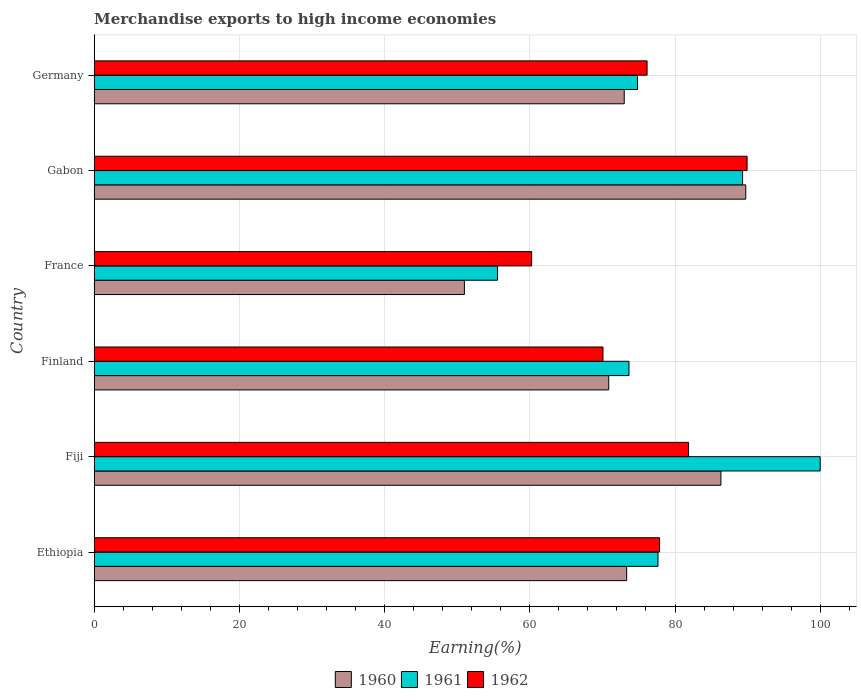How many groups of bars are there?
Offer a terse response. 6. Are the number of bars on each tick of the Y-axis equal?
Ensure brevity in your answer.  Yes. What is the label of the 5th group of bars from the top?
Ensure brevity in your answer.  Fiji. In how many cases, is the number of bars for a given country not equal to the number of legend labels?
Provide a succinct answer. 0. What is the percentage of amount earned from merchandise exports in 1960 in Ethiopia?
Make the answer very short. 73.34. Across all countries, what is the maximum percentage of amount earned from merchandise exports in 1962?
Provide a short and direct response. 89.93. Across all countries, what is the minimum percentage of amount earned from merchandise exports in 1960?
Your response must be concise. 50.99. In which country was the percentage of amount earned from merchandise exports in 1960 maximum?
Make the answer very short. Gabon. What is the total percentage of amount earned from merchandise exports in 1960 in the graph?
Keep it short and to the point. 444.29. What is the difference between the percentage of amount earned from merchandise exports in 1961 in France and that in Germany?
Make the answer very short. -19.28. What is the difference between the percentage of amount earned from merchandise exports in 1962 in Germany and the percentage of amount earned from merchandise exports in 1961 in Fiji?
Give a very brief answer. -23.85. What is the average percentage of amount earned from merchandise exports in 1962 per country?
Keep it short and to the point. 76.03. What is the difference between the percentage of amount earned from merchandise exports in 1962 and percentage of amount earned from merchandise exports in 1960 in France?
Your response must be concise. 9.26. In how many countries, is the percentage of amount earned from merchandise exports in 1961 greater than 88 %?
Offer a terse response. 2. What is the ratio of the percentage of amount earned from merchandise exports in 1962 in Ethiopia to that in Fiji?
Provide a short and direct response. 0.95. What is the difference between the highest and the second highest percentage of amount earned from merchandise exports in 1961?
Provide a succinct answer. 10.69. What is the difference between the highest and the lowest percentage of amount earned from merchandise exports in 1960?
Keep it short and to the point. 38.76. Is the sum of the percentage of amount earned from merchandise exports in 1961 in Fiji and Gabon greater than the maximum percentage of amount earned from merchandise exports in 1962 across all countries?
Ensure brevity in your answer.  Yes. Is it the case that in every country, the sum of the percentage of amount earned from merchandise exports in 1960 and percentage of amount earned from merchandise exports in 1961 is greater than the percentage of amount earned from merchandise exports in 1962?
Provide a short and direct response. Yes. How many countries are there in the graph?
Your response must be concise. 6. Are the values on the major ticks of X-axis written in scientific E-notation?
Give a very brief answer. No. Does the graph contain any zero values?
Your response must be concise. No. Does the graph contain grids?
Provide a succinct answer. Yes. What is the title of the graph?
Your answer should be very brief. Merchandise exports to high income economies. Does "1999" appear as one of the legend labels in the graph?
Offer a terse response. No. What is the label or title of the X-axis?
Your answer should be very brief. Earning(%). What is the label or title of the Y-axis?
Provide a succinct answer. Country. What is the Earning(%) in 1960 in Ethiopia?
Offer a very short reply. 73.34. What is the Earning(%) of 1961 in Ethiopia?
Your answer should be very brief. 77.66. What is the Earning(%) in 1962 in Ethiopia?
Your answer should be compact. 77.88. What is the Earning(%) of 1960 in Fiji?
Ensure brevity in your answer.  86.33. What is the Earning(%) in 1962 in Fiji?
Make the answer very short. 81.86. What is the Earning(%) of 1960 in Finland?
Make the answer very short. 70.87. What is the Earning(%) of 1961 in Finland?
Provide a succinct answer. 73.67. What is the Earning(%) of 1962 in Finland?
Your response must be concise. 70.08. What is the Earning(%) of 1960 in France?
Offer a terse response. 50.99. What is the Earning(%) of 1961 in France?
Keep it short and to the point. 55.56. What is the Earning(%) in 1962 in France?
Give a very brief answer. 60.25. What is the Earning(%) in 1960 in Gabon?
Keep it short and to the point. 89.75. What is the Earning(%) in 1961 in Gabon?
Provide a succinct answer. 89.31. What is the Earning(%) in 1962 in Gabon?
Make the answer very short. 89.93. What is the Earning(%) in 1960 in Germany?
Ensure brevity in your answer.  73.01. What is the Earning(%) of 1961 in Germany?
Offer a terse response. 74.84. What is the Earning(%) of 1962 in Germany?
Your answer should be compact. 76.15. Across all countries, what is the maximum Earning(%) in 1960?
Your response must be concise. 89.75. Across all countries, what is the maximum Earning(%) in 1961?
Offer a very short reply. 100. Across all countries, what is the maximum Earning(%) of 1962?
Ensure brevity in your answer.  89.93. Across all countries, what is the minimum Earning(%) of 1960?
Provide a short and direct response. 50.99. Across all countries, what is the minimum Earning(%) of 1961?
Offer a very short reply. 55.56. Across all countries, what is the minimum Earning(%) in 1962?
Ensure brevity in your answer.  60.25. What is the total Earning(%) in 1960 in the graph?
Ensure brevity in your answer.  444.29. What is the total Earning(%) in 1961 in the graph?
Ensure brevity in your answer.  471.03. What is the total Earning(%) of 1962 in the graph?
Your answer should be compact. 456.16. What is the difference between the Earning(%) of 1960 in Ethiopia and that in Fiji?
Your response must be concise. -12.99. What is the difference between the Earning(%) in 1961 in Ethiopia and that in Fiji?
Keep it short and to the point. -22.34. What is the difference between the Earning(%) in 1962 in Ethiopia and that in Fiji?
Your answer should be very brief. -3.99. What is the difference between the Earning(%) of 1960 in Ethiopia and that in Finland?
Your response must be concise. 2.47. What is the difference between the Earning(%) of 1961 in Ethiopia and that in Finland?
Keep it short and to the point. 3.99. What is the difference between the Earning(%) of 1962 in Ethiopia and that in Finland?
Offer a terse response. 7.8. What is the difference between the Earning(%) of 1960 in Ethiopia and that in France?
Your answer should be compact. 22.35. What is the difference between the Earning(%) of 1961 in Ethiopia and that in France?
Your response must be concise. 22.1. What is the difference between the Earning(%) in 1962 in Ethiopia and that in France?
Offer a terse response. 17.62. What is the difference between the Earning(%) of 1960 in Ethiopia and that in Gabon?
Provide a short and direct response. -16.41. What is the difference between the Earning(%) of 1961 in Ethiopia and that in Gabon?
Offer a very short reply. -11.65. What is the difference between the Earning(%) of 1962 in Ethiopia and that in Gabon?
Your answer should be compact. -12.06. What is the difference between the Earning(%) in 1960 in Ethiopia and that in Germany?
Keep it short and to the point. 0.33. What is the difference between the Earning(%) in 1961 in Ethiopia and that in Germany?
Keep it short and to the point. 2.82. What is the difference between the Earning(%) in 1962 in Ethiopia and that in Germany?
Offer a terse response. 1.72. What is the difference between the Earning(%) of 1960 in Fiji and that in Finland?
Your answer should be compact. 15.46. What is the difference between the Earning(%) in 1961 in Fiji and that in Finland?
Your answer should be compact. 26.33. What is the difference between the Earning(%) in 1962 in Fiji and that in Finland?
Your answer should be very brief. 11.79. What is the difference between the Earning(%) in 1960 in Fiji and that in France?
Your response must be concise. 35.34. What is the difference between the Earning(%) in 1961 in Fiji and that in France?
Your answer should be compact. 44.44. What is the difference between the Earning(%) of 1962 in Fiji and that in France?
Your answer should be compact. 21.61. What is the difference between the Earning(%) in 1960 in Fiji and that in Gabon?
Ensure brevity in your answer.  -3.42. What is the difference between the Earning(%) of 1961 in Fiji and that in Gabon?
Your answer should be compact. 10.69. What is the difference between the Earning(%) in 1962 in Fiji and that in Gabon?
Offer a terse response. -8.07. What is the difference between the Earning(%) in 1960 in Fiji and that in Germany?
Keep it short and to the point. 13.32. What is the difference between the Earning(%) in 1961 in Fiji and that in Germany?
Your response must be concise. 25.16. What is the difference between the Earning(%) in 1962 in Fiji and that in Germany?
Keep it short and to the point. 5.71. What is the difference between the Earning(%) in 1960 in Finland and that in France?
Your answer should be compact. 19.88. What is the difference between the Earning(%) in 1961 in Finland and that in France?
Your response must be concise. 18.11. What is the difference between the Earning(%) of 1962 in Finland and that in France?
Offer a very short reply. 9.83. What is the difference between the Earning(%) in 1960 in Finland and that in Gabon?
Your answer should be compact. -18.88. What is the difference between the Earning(%) in 1961 in Finland and that in Gabon?
Provide a succinct answer. -15.65. What is the difference between the Earning(%) in 1962 in Finland and that in Gabon?
Offer a very short reply. -19.85. What is the difference between the Earning(%) of 1960 in Finland and that in Germany?
Keep it short and to the point. -2.13. What is the difference between the Earning(%) in 1961 in Finland and that in Germany?
Your answer should be compact. -1.17. What is the difference between the Earning(%) in 1962 in Finland and that in Germany?
Offer a terse response. -6.08. What is the difference between the Earning(%) of 1960 in France and that in Gabon?
Give a very brief answer. -38.76. What is the difference between the Earning(%) of 1961 in France and that in Gabon?
Make the answer very short. -33.76. What is the difference between the Earning(%) of 1962 in France and that in Gabon?
Keep it short and to the point. -29.68. What is the difference between the Earning(%) in 1960 in France and that in Germany?
Offer a very short reply. -22.02. What is the difference between the Earning(%) in 1961 in France and that in Germany?
Your answer should be very brief. -19.28. What is the difference between the Earning(%) in 1962 in France and that in Germany?
Offer a terse response. -15.9. What is the difference between the Earning(%) of 1960 in Gabon and that in Germany?
Keep it short and to the point. 16.74. What is the difference between the Earning(%) of 1961 in Gabon and that in Germany?
Your answer should be compact. 14.47. What is the difference between the Earning(%) in 1962 in Gabon and that in Germany?
Offer a terse response. 13.78. What is the difference between the Earning(%) of 1960 in Ethiopia and the Earning(%) of 1961 in Fiji?
Provide a short and direct response. -26.66. What is the difference between the Earning(%) in 1960 in Ethiopia and the Earning(%) in 1962 in Fiji?
Offer a terse response. -8.52. What is the difference between the Earning(%) in 1961 in Ethiopia and the Earning(%) in 1962 in Fiji?
Ensure brevity in your answer.  -4.2. What is the difference between the Earning(%) of 1960 in Ethiopia and the Earning(%) of 1961 in Finland?
Your answer should be compact. -0.32. What is the difference between the Earning(%) in 1960 in Ethiopia and the Earning(%) in 1962 in Finland?
Your answer should be very brief. 3.26. What is the difference between the Earning(%) in 1961 in Ethiopia and the Earning(%) in 1962 in Finland?
Your response must be concise. 7.58. What is the difference between the Earning(%) in 1960 in Ethiopia and the Earning(%) in 1961 in France?
Provide a short and direct response. 17.79. What is the difference between the Earning(%) of 1960 in Ethiopia and the Earning(%) of 1962 in France?
Make the answer very short. 13.09. What is the difference between the Earning(%) of 1961 in Ethiopia and the Earning(%) of 1962 in France?
Your answer should be very brief. 17.41. What is the difference between the Earning(%) of 1960 in Ethiopia and the Earning(%) of 1961 in Gabon?
Offer a terse response. -15.97. What is the difference between the Earning(%) in 1960 in Ethiopia and the Earning(%) in 1962 in Gabon?
Provide a short and direct response. -16.59. What is the difference between the Earning(%) in 1961 in Ethiopia and the Earning(%) in 1962 in Gabon?
Ensure brevity in your answer.  -12.27. What is the difference between the Earning(%) of 1960 in Ethiopia and the Earning(%) of 1961 in Germany?
Provide a succinct answer. -1.5. What is the difference between the Earning(%) in 1960 in Ethiopia and the Earning(%) in 1962 in Germany?
Keep it short and to the point. -2.81. What is the difference between the Earning(%) in 1961 in Ethiopia and the Earning(%) in 1962 in Germany?
Ensure brevity in your answer.  1.51. What is the difference between the Earning(%) of 1960 in Fiji and the Earning(%) of 1961 in Finland?
Make the answer very short. 12.66. What is the difference between the Earning(%) of 1960 in Fiji and the Earning(%) of 1962 in Finland?
Ensure brevity in your answer.  16.25. What is the difference between the Earning(%) in 1961 in Fiji and the Earning(%) in 1962 in Finland?
Keep it short and to the point. 29.92. What is the difference between the Earning(%) in 1960 in Fiji and the Earning(%) in 1961 in France?
Make the answer very short. 30.77. What is the difference between the Earning(%) of 1960 in Fiji and the Earning(%) of 1962 in France?
Offer a very short reply. 26.08. What is the difference between the Earning(%) of 1961 in Fiji and the Earning(%) of 1962 in France?
Provide a short and direct response. 39.75. What is the difference between the Earning(%) in 1960 in Fiji and the Earning(%) in 1961 in Gabon?
Your answer should be very brief. -2.98. What is the difference between the Earning(%) of 1960 in Fiji and the Earning(%) of 1962 in Gabon?
Provide a short and direct response. -3.6. What is the difference between the Earning(%) of 1961 in Fiji and the Earning(%) of 1962 in Gabon?
Offer a very short reply. 10.07. What is the difference between the Earning(%) of 1960 in Fiji and the Earning(%) of 1961 in Germany?
Your response must be concise. 11.49. What is the difference between the Earning(%) of 1960 in Fiji and the Earning(%) of 1962 in Germany?
Keep it short and to the point. 10.18. What is the difference between the Earning(%) in 1961 in Fiji and the Earning(%) in 1962 in Germany?
Ensure brevity in your answer.  23.85. What is the difference between the Earning(%) of 1960 in Finland and the Earning(%) of 1961 in France?
Provide a succinct answer. 15.32. What is the difference between the Earning(%) in 1960 in Finland and the Earning(%) in 1962 in France?
Offer a terse response. 10.62. What is the difference between the Earning(%) in 1961 in Finland and the Earning(%) in 1962 in France?
Ensure brevity in your answer.  13.41. What is the difference between the Earning(%) of 1960 in Finland and the Earning(%) of 1961 in Gabon?
Keep it short and to the point. -18.44. What is the difference between the Earning(%) of 1960 in Finland and the Earning(%) of 1962 in Gabon?
Make the answer very short. -19.06. What is the difference between the Earning(%) of 1961 in Finland and the Earning(%) of 1962 in Gabon?
Keep it short and to the point. -16.27. What is the difference between the Earning(%) of 1960 in Finland and the Earning(%) of 1961 in Germany?
Make the answer very short. -3.96. What is the difference between the Earning(%) of 1960 in Finland and the Earning(%) of 1962 in Germany?
Offer a very short reply. -5.28. What is the difference between the Earning(%) of 1961 in Finland and the Earning(%) of 1962 in Germany?
Keep it short and to the point. -2.49. What is the difference between the Earning(%) in 1960 in France and the Earning(%) in 1961 in Gabon?
Your answer should be very brief. -38.32. What is the difference between the Earning(%) in 1960 in France and the Earning(%) in 1962 in Gabon?
Your answer should be very brief. -38.94. What is the difference between the Earning(%) in 1961 in France and the Earning(%) in 1962 in Gabon?
Ensure brevity in your answer.  -34.38. What is the difference between the Earning(%) of 1960 in France and the Earning(%) of 1961 in Germany?
Offer a very short reply. -23.85. What is the difference between the Earning(%) of 1960 in France and the Earning(%) of 1962 in Germany?
Your response must be concise. -25.16. What is the difference between the Earning(%) in 1961 in France and the Earning(%) in 1962 in Germany?
Keep it short and to the point. -20.6. What is the difference between the Earning(%) of 1960 in Gabon and the Earning(%) of 1961 in Germany?
Your response must be concise. 14.91. What is the difference between the Earning(%) in 1960 in Gabon and the Earning(%) in 1962 in Germany?
Your response must be concise. 13.59. What is the difference between the Earning(%) of 1961 in Gabon and the Earning(%) of 1962 in Germany?
Offer a terse response. 13.16. What is the average Earning(%) of 1960 per country?
Your response must be concise. 74.05. What is the average Earning(%) in 1961 per country?
Your response must be concise. 78.51. What is the average Earning(%) of 1962 per country?
Provide a short and direct response. 76.03. What is the difference between the Earning(%) of 1960 and Earning(%) of 1961 in Ethiopia?
Offer a terse response. -4.32. What is the difference between the Earning(%) in 1960 and Earning(%) in 1962 in Ethiopia?
Provide a succinct answer. -4.53. What is the difference between the Earning(%) of 1961 and Earning(%) of 1962 in Ethiopia?
Your answer should be compact. -0.22. What is the difference between the Earning(%) in 1960 and Earning(%) in 1961 in Fiji?
Ensure brevity in your answer.  -13.67. What is the difference between the Earning(%) of 1960 and Earning(%) of 1962 in Fiji?
Provide a short and direct response. 4.47. What is the difference between the Earning(%) of 1961 and Earning(%) of 1962 in Fiji?
Offer a terse response. 18.14. What is the difference between the Earning(%) of 1960 and Earning(%) of 1961 in Finland?
Keep it short and to the point. -2.79. What is the difference between the Earning(%) of 1960 and Earning(%) of 1962 in Finland?
Offer a terse response. 0.79. What is the difference between the Earning(%) of 1961 and Earning(%) of 1962 in Finland?
Provide a short and direct response. 3.59. What is the difference between the Earning(%) of 1960 and Earning(%) of 1961 in France?
Offer a very short reply. -4.56. What is the difference between the Earning(%) of 1960 and Earning(%) of 1962 in France?
Offer a very short reply. -9.26. What is the difference between the Earning(%) in 1961 and Earning(%) in 1962 in France?
Make the answer very short. -4.7. What is the difference between the Earning(%) in 1960 and Earning(%) in 1961 in Gabon?
Provide a short and direct response. 0.44. What is the difference between the Earning(%) of 1960 and Earning(%) of 1962 in Gabon?
Your answer should be very brief. -0.18. What is the difference between the Earning(%) in 1961 and Earning(%) in 1962 in Gabon?
Keep it short and to the point. -0.62. What is the difference between the Earning(%) of 1960 and Earning(%) of 1961 in Germany?
Make the answer very short. -1.83. What is the difference between the Earning(%) of 1960 and Earning(%) of 1962 in Germany?
Your answer should be very brief. -3.15. What is the difference between the Earning(%) of 1961 and Earning(%) of 1962 in Germany?
Your response must be concise. -1.32. What is the ratio of the Earning(%) of 1960 in Ethiopia to that in Fiji?
Make the answer very short. 0.85. What is the ratio of the Earning(%) in 1961 in Ethiopia to that in Fiji?
Your answer should be compact. 0.78. What is the ratio of the Earning(%) in 1962 in Ethiopia to that in Fiji?
Your response must be concise. 0.95. What is the ratio of the Earning(%) of 1960 in Ethiopia to that in Finland?
Your response must be concise. 1.03. What is the ratio of the Earning(%) of 1961 in Ethiopia to that in Finland?
Provide a short and direct response. 1.05. What is the ratio of the Earning(%) of 1962 in Ethiopia to that in Finland?
Offer a terse response. 1.11. What is the ratio of the Earning(%) in 1960 in Ethiopia to that in France?
Keep it short and to the point. 1.44. What is the ratio of the Earning(%) of 1961 in Ethiopia to that in France?
Offer a terse response. 1.4. What is the ratio of the Earning(%) of 1962 in Ethiopia to that in France?
Ensure brevity in your answer.  1.29. What is the ratio of the Earning(%) of 1960 in Ethiopia to that in Gabon?
Your response must be concise. 0.82. What is the ratio of the Earning(%) of 1961 in Ethiopia to that in Gabon?
Your answer should be very brief. 0.87. What is the ratio of the Earning(%) of 1962 in Ethiopia to that in Gabon?
Your answer should be very brief. 0.87. What is the ratio of the Earning(%) of 1960 in Ethiopia to that in Germany?
Ensure brevity in your answer.  1. What is the ratio of the Earning(%) of 1961 in Ethiopia to that in Germany?
Provide a short and direct response. 1.04. What is the ratio of the Earning(%) in 1962 in Ethiopia to that in Germany?
Provide a succinct answer. 1.02. What is the ratio of the Earning(%) in 1960 in Fiji to that in Finland?
Give a very brief answer. 1.22. What is the ratio of the Earning(%) in 1961 in Fiji to that in Finland?
Keep it short and to the point. 1.36. What is the ratio of the Earning(%) in 1962 in Fiji to that in Finland?
Your answer should be compact. 1.17. What is the ratio of the Earning(%) of 1960 in Fiji to that in France?
Offer a very short reply. 1.69. What is the ratio of the Earning(%) in 1962 in Fiji to that in France?
Offer a very short reply. 1.36. What is the ratio of the Earning(%) of 1960 in Fiji to that in Gabon?
Provide a short and direct response. 0.96. What is the ratio of the Earning(%) of 1961 in Fiji to that in Gabon?
Keep it short and to the point. 1.12. What is the ratio of the Earning(%) of 1962 in Fiji to that in Gabon?
Give a very brief answer. 0.91. What is the ratio of the Earning(%) in 1960 in Fiji to that in Germany?
Ensure brevity in your answer.  1.18. What is the ratio of the Earning(%) of 1961 in Fiji to that in Germany?
Offer a very short reply. 1.34. What is the ratio of the Earning(%) of 1962 in Fiji to that in Germany?
Make the answer very short. 1.07. What is the ratio of the Earning(%) of 1960 in Finland to that in France?
Ensure brevity in your answer.  1.39. What is the ratio of the Earning(%) of 1961 in Finland to that in France?
Make the answer very short. 1.33. What is the ratio of the Earning(%) in 1962 in Finland to that in France?
Provide a short and direct response. 1.16. What is the ratio of the Earning(%) in 1960 in Finland to that in Gabon?
Your answer should be compact. 0.79. What is the ratio of the Earning(%) of 1961 in Finland to that in Gabon?
Keep it short and to the point. 0.82. What is the ratio of the Earning(%) of 1962 in Finland to that in Gabon?
Provide a short and direct response. 0.78. What is the ratio of the Earning(%) of 1960 in Finland to that in Germany?
Make the answer very short. 0.97. What is the ratio of the Earning(%) in 1961 in Finland to that in Germany?
Offer a very short reply. 0.98. What is the ratio of the Earning(%) of 1962 in Finland to that in Germany?
Your response must be concise. 0.92. What is the ratio of the Earning(%) of 1960 in France to that in Gabon?
Make the answer very short. 0.57. What is the ratio of the Earning(%) of 1961 in France to that in Gabon?
Ensure brevity in your answer.  0.62. What is the ratio of the Earning(%) in 1962 in France to that in Gabon?
Ensure brevity in your answer.  0.67. What is the ratio of the Earning(%) in 1960 in France to that in Germany?
Make the answer very short. 0.7. What is the ratio of the Earning(%) of 1961 in France to that in Germany?
Keep it short and to the point. 0.74. What is the ratio of the Earning(%) in 1962 in France to that in Germany?
Offer a very short reply. 0.79. What is the ratio of the Earning(%) of 1960 in Gabon to that in Germany?
Keep it short and to the point. 1.23. What is the ratio of the Earning(%) in 1961 in Gabon to that in Germany?
Make the answer very short. 1.19. What is the ratio of the Earning(%) of 1962 in Gabon to that in Germany?
Offer a very short reply. 1.18. What is the difference between the highest and the second highest Earning(%) in 1960?
Provide a succinct answer. 3.42. What is the difference between the highest and the second highest Earning(%) of 1961?
Keep it short and to the point. 10.69. What is the difference between the highest and the second highest Earning(%) in 1962?
Make the answer very short. 8.07. What is the difference between the highest and the lowest Earning(%) of 1960?
Keep it short and to the point. 38.76. What is the difference between the highest and the lowest Earning(%) in 1961?
Keep it short and to the point. 44.44. What is the difference between the highest and the lowest Earning(%) of 1962?
Your answer should be very brief. 29.68. 